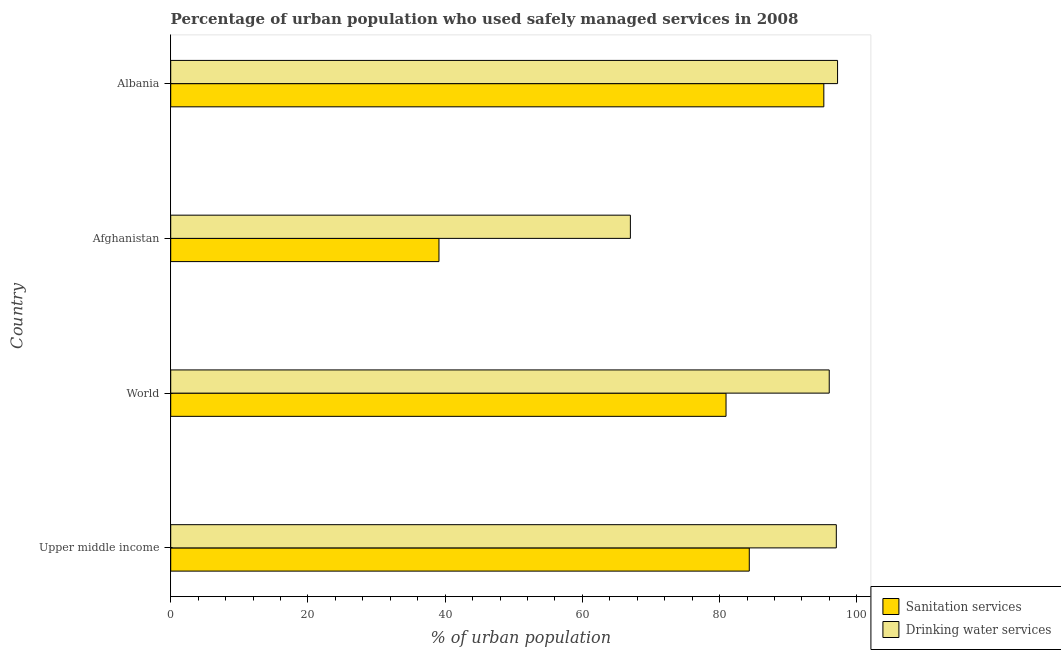Are the number of bars per tick equal to the number of legend labels?
Keep it short and to the point. Yes. Are the number of bars on each tick of the Y-axis equal?
Offer a very short reply. Yes. How many bars are there on the 1st tick from the top?
Make the answer very short. 2. How many bars are there on the 1st tick from the bottom?
Provide a short and direct response. 2. What is the label of the 1st group of bars from the top?
Ensure brevity in your answer.  Albania. In how many cases, is the number of bars for a given country not equal to the number of legend labels?
Provide a short and direct response. 0. What is the percentage of urban population who used sanitation services in Afghanistan?
Provide a succinct answer. 39.1. Across all countries, what is the maximum percentage of urban population who used drinking water services?
Your answer should be compact. 97.2. Across all countries, what is the minimum percentage of urban population who used sanitation services?
Keep it short and to the point. 39.1. In which country was the percentage of urban population who used sanitation services maximum?
Your response must be concise. Albania. In which country was the percentage of urban population who used drinking water services minimum?
Your response must be concise. Afghanistan. What is the total percentage of urban population who used sanitation services in the graph?
Provide a succinct answer. 299.58. What is the difference between the percentage of urban population who used drinking water services in Albania and that in World?
Give a very brief answer. 1.21. What is the difference between the percentage of urban population who used drinking water services in Albania and the percentage of urban population who used sanitation services in Afghanistan?
Your response must be concise. 58.1. What is the average percentage of urban population who used sanitation services per country?
Your answer should be very brief. 74.89. What is the difference between the percentage of urban population who used drinking water services and percentage of urban population who used sanitation services in World?
Ensure brevity in your answer.  15.04. In how many countries, is the percentage of urban population who used sanitation services greater than 40 %?
Your answer should be compact. 3. What is the ratio of the percentage of urban population who used sanitation services in Albania to that in World?
Provide a short and direct response. 1.18. Is the percentage of urban population who used sanitation services in Afghanistan less than that in World?
Provide a succinct answer. Yes. What is the difference between the highest and the second highest percentage of urban population who used drinking water services?
Give a very brief answer. 0.18. What is the difference between the highest and the lowest percentage of urban population who used sanitation services?
Give a very brief answer. 56.1. Is the sum of the percentage of urban population who used sanitation services in Afghanistan and Upper middle income greater than the maximum percentage of urban population who used drinking water services across all countries?
Your response must be concise. Yes. What does the 1st bar from the top in Upper middle income represents?
Your answer should be very brief. Drinking water services. What does the 1st bar from the bottom in Upper middle income represents?
Offer a terse response. Sanitation services. How many bars are there?
Offer a terse response. 8. Are all the bars in the graph horizontal?
Provide a short and direct response. Yes. How many countries are there in the graph?
Provide a short and direct response. 4. Does the graph contain any zero values?
Make the answer very short. No. Does the graph contain grids?
Your answer should be compact. No. Where does the legend appear in the graph?
Your answer should be compact. Bottom right. What is the title of the graph?
Provide a short and direct response. Percentage of urban population who used safely managed services in 2008. Does "Net National savings" appear as one of the legend labels in the graph?
Offer a terse response. No. What is the label or title of the X-axis?
Provide a short and direct response. % of urban population. What is the label or title of the Y-axis?
Give a very brief answer. Country. What is the % of urban population in Sanitation services in Upper middle income?
Keep it short and to the point. 84.33. What is the % of urban population of Drinking water services in Upper middle income?
Provide a short and direct response. 97.02. What is the % of urban population in Sanitation services in World?
Your response must be concise. 80.94. What is the % of urban population of Drinking water services in World?
Offer a terse response. 95.99. What is the % of urban population of Sanitation services in Afghanistan?
Keep it short and to the point. 39.1. What is the % of urban population in Drinking water services in Afghanistan?
Make the answer very short. 67. What is the % of urban population in Sanitation services in Albania?
Make the answer very short. 95.2. What is the % of urban population of Drinking water services in Albania?
Keep it short and to the point. 97.2. Across all countries, what is the maximum % of urban population of Sanitation services?
Ensure brevity in your answer.  95.2. Across all countries, what is the maximum % of urban population in Drinking water services?
Offer a terse response. 97.2. Across all countries, what is the minimum % of urban population in Sanitation services?
Keep it short and to the point. 39.1. Across all countries, what is the minimum % of urban population in Drinking water services?
Ensure brevity in your answer.  67. What is the total % of urban population of Sanitation services in the graph?
Ensure brevity in your answer.  299.58. What is the total % of urban population of Drinking water services in the graph?
Offer a very short reply. 357.21. What is the difference between the % of urban population of Sanitation services in Upper middle income and that in World?
Offer a terse response. 3.39. What is the difference between the % of urban population in Drinking water services in Upper middle income and that in World?
Offer a very short reply. 1.03. What is the difference between the % of urban population in Sanitation services in Upper middle income and that in Afghanistan?
Ensure brevity in your answer.  45.23. What is the difference between the % of urban population in Drinking water services in Upper middle income and that in Afghanistan?
Give a very brief answer. 30.02. What is the difference between the % of urban population of Sanitation services in Upper middle income and that in Albania?
Offer a very short reply. -10.87. What is the difference between the % of urban population in Drinking water services in Upper middle income and that in Albania?
Your answer should be very brief. -0.18. What is the difference between the % of urban population in Sanitation services in World and that in Afghanistan?
Provide a succinct answer. 41.84. What is the difference between the % of urban population of Drinking water services in World and that in Afghanistan?
Your answer should be compact. 28.99. What is the difference between the % of urban population in Sanitation services in World and that in Albania?
Your answer should be very brief. -14.26. What is the difference between the % of urban population of Drinking water services in World and that in Albania?
Provide a short and direct response. -1.21. What is the difference between the % of urban population in Sanitation services in Afghanistan and that in Albania?
Your answer should be compact. -56.1. What is the difference between the % of urban population of Drinking water services in Afghanistan and that in Albania?
Make the answer very short. -30.2. What is the difference between the % of urban population in Sanitation services in Upper middle income and the % of urban population in Drinking water services in World?
Keep it short and to the point. -11.65. What is the difference between the % of urban population of Sanitation services in Upper middle income and the % of urban population of Drinking water services in Afghanistan?
Keep it short and to the point. 17.33. What is the difference between the % of urban population in Sanitation services in Upper middle income and the % of urban population in Drinking water services in Albania?
Make the answer very short. -12.87. What is the difference between the % of urban population in Sanitation services in World and the % of urban population in Drinking water services in Afghanistan?
Your answer should be very brief. 13.94. What is the difference between the % of urban population in Sanitation services in World and the % of urban population in Drinking water services in Albania?
Provide a succinct answer. -16.26. What is the difference between the % of urban population in Sanitation services in Afghanistan and the % of urban population in Drinking water services in Albania?
Offer a terse response. -58.1. What is the average % of urban population of Sanitation services per country?
Ensure brevity in your answer.  74.89. What is the average % of urban population in Drinking water services per country?
Ensure brevity in your answer.  89.3. What is the difference between the % of urban population of Sanitation services and % of urban population of Drinking water services in Upper middle income?
Keep it short and to the point. -12.69. What is the difference between the % of urban population of Sanitation services and % of urban population of Drinking water services in World?
Keep it short and to the point. -15.04. What is the difference between the % of urban population in Sanitation services and % of urban population in Drinking water services in Afghanistan?
Offer a very short reply. -27.9. What is the ratio of the % of urban population of Sanitation services in Upper middle income to that in World?
Give a very brief answer. 1.04. What is the ratio of the % of urban population of Drinking water services in Upper middle income to that in World?
Your answer should be compact. 1.01. What is the ratio of the % of urban population of Sanitation services in Upper middle income to that in Afghanistan?
Offer a terse response. 2.16. What is the ratio of the % of urban population of Drinking water services in Upper middle income to that in Afghanistan?
Your response must be concise. 1.45. What is the ratio of the % of urban population in Sanitation services in Upper middle income to that in Albania?
Your answer should be very brief. 0.89. What is the ratio of the % of urban population in Sanitation services in World to that in Afghanistan?
Offer a terse response. 2.07. What is the ratio of the % of urban population in Drinking water services in World to that in Afghanistan?
Make the answer very short. 1.43. What is the ratio of the % of urban population in Sanitation services in World to that in Albania?
Offer a terse response. 0.85. What is the ratio of the % of urban population of Drinking water services in World to that in Albania?
Offer a terse response. 0.99. What is the ratio of the % of urban population of Sanitation services in Afghanistan to that in Albania?
Your answer should be very brief. 0.41. What is the ratio of the % of urban population in Drinking water services in Afghanistan to that in Albania?
Keep it short and to the point. 0.69. What is the difference between the highest and the second highest % of urban population in Sanitation services?
Your response must be concise. 10.87. What is the difference between the highest and the second highest % of urban population of Drinking water services?
Your answer should be compact. 0.18. What is the difference between the highest and the lowest % of urban population in Sanitation services?
Provide a short and direct response. 56.1. What is the difference between the highest and the lowest % of urban population in Drinking water services?
Give a very brief answer. 30.2. 